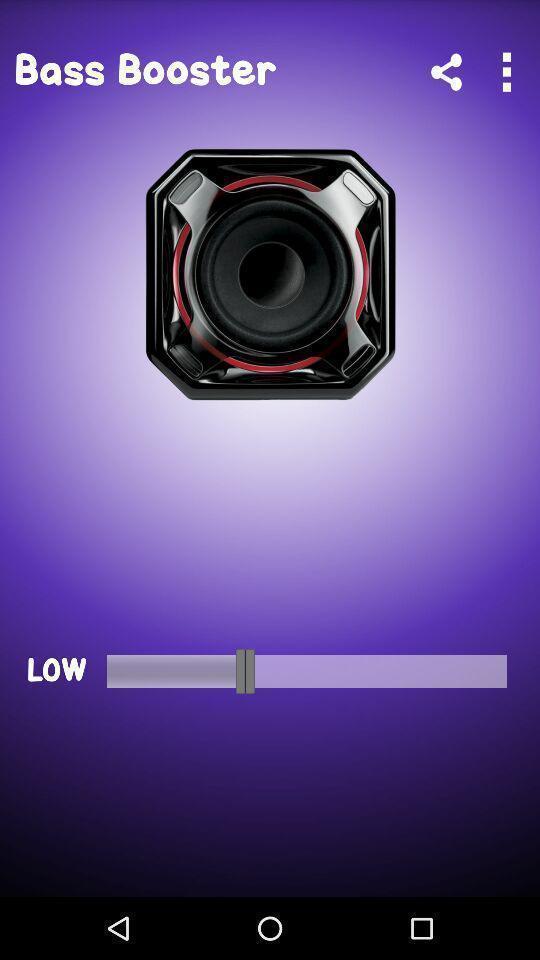What is the overall content of this screenshot? Page is showing volume option. 